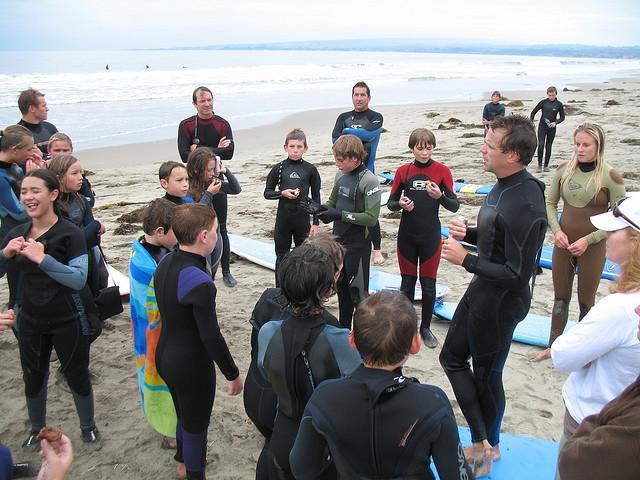What sport are these people participating in?
Concise answer only. Surfing. Are the people wearing swimsuits?
Write a very short answer. No. How many people are wearing black?
Write a very short answer. 18. How many people are wrapped in towels?
Keep it brief. 1. 